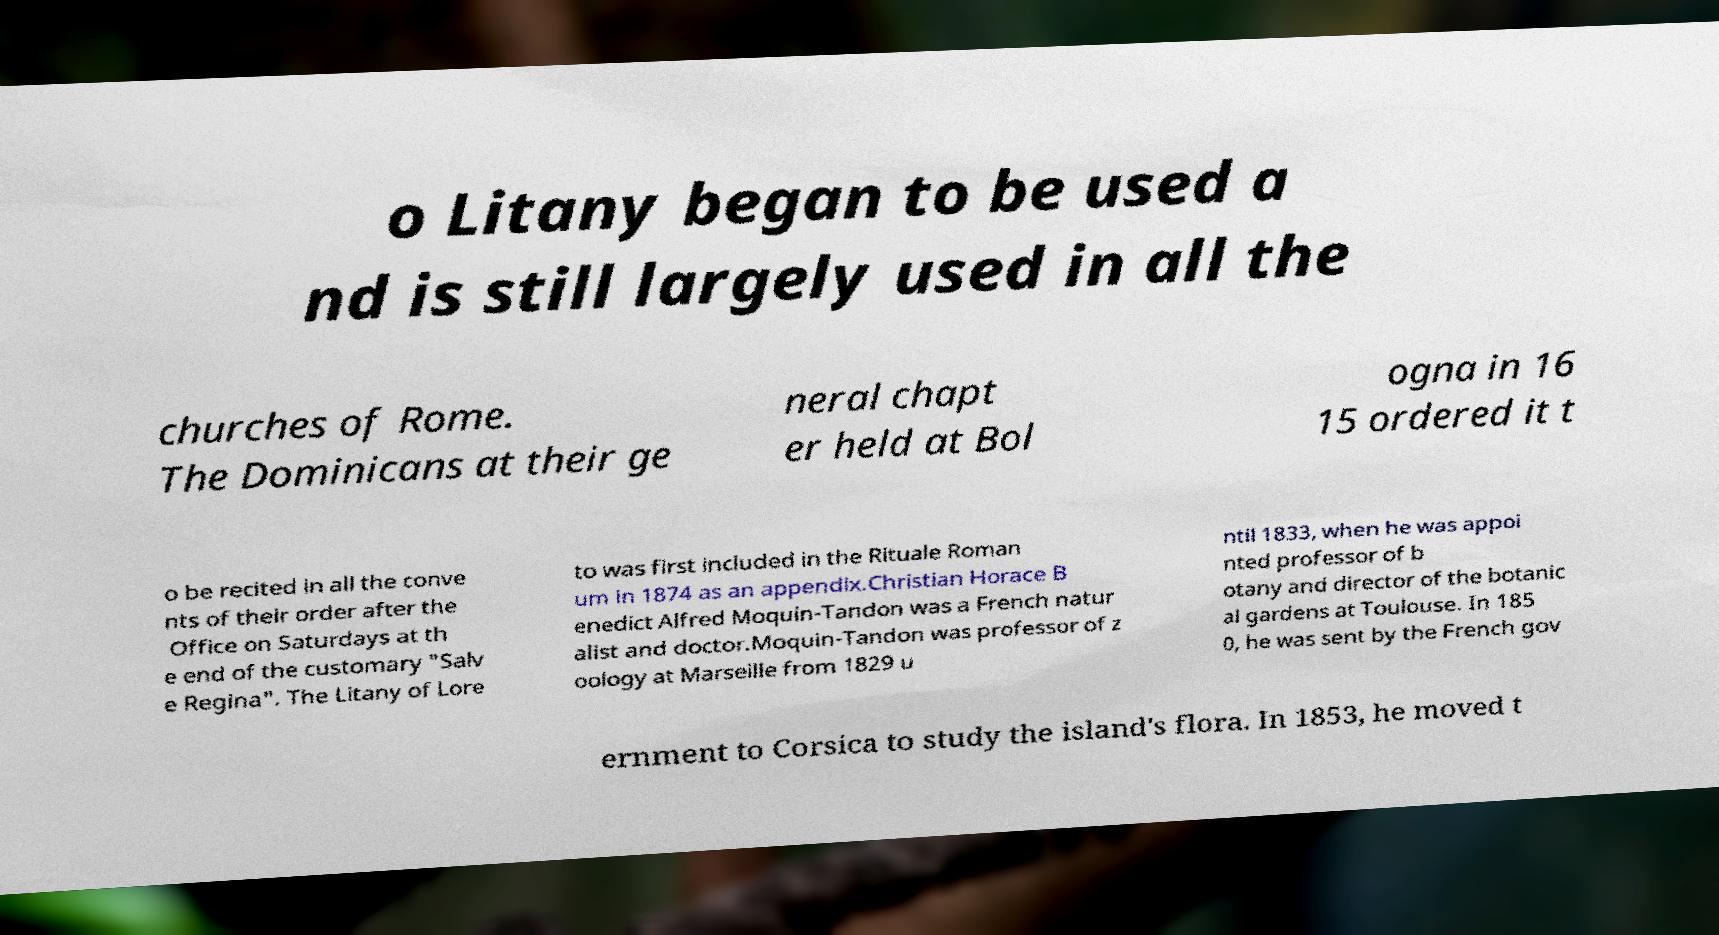Could you assist in decoding the text presented in this image and type it out clearly? o Litany began to be used a nd is still largely used in all the churches of Rome. The Dominicans at their ge neral chapt er held at Bol ogna in 16 15 ordered it t o be recited in all the conve nts of their order after the Office on Saturdays at th e end of the customary "Salv e Regina". The Litany of Lore to was first included in the Rituale Roman um in 1874 as an appendix.Christian Horace B enedict Alfred Moquin-Tandon was a French natur alist and doctor.Moquin-Tandon was professor of z oology at Marseille from 1829 u ntil 1833, when he was appoi nted professor of b otany and director of the botanic al gardens at Toulouse. In 185 0, he was sent by the French gov ernment to Corsica to study the island's flora. In 1853, he moved t 